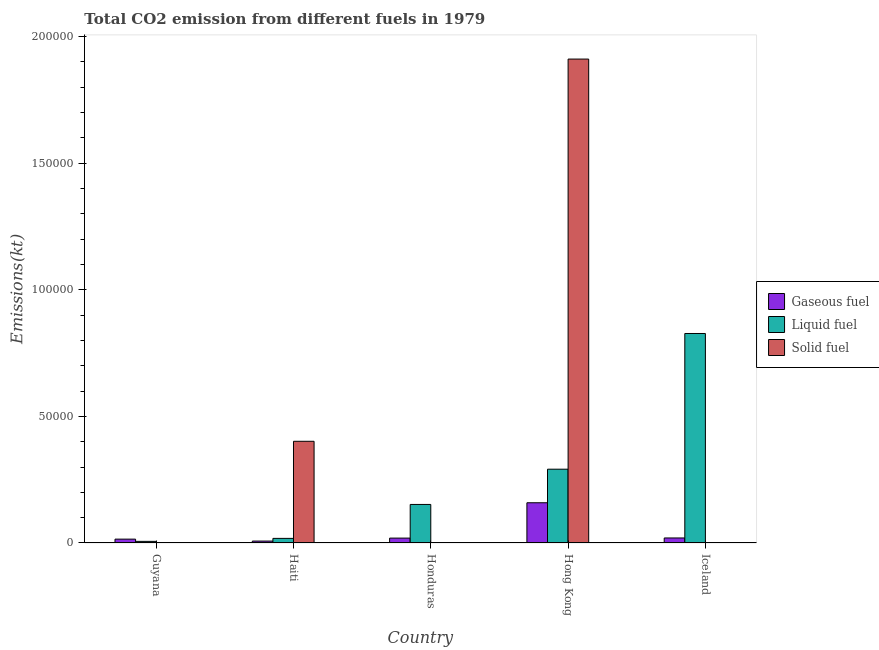How many groups of bars are there?
Keep it short and to the point. 5. How many bars are there on the 4th tick from the right?
Provide a short and direct response. 3. What is the label of the 4th group of bars from the left?
Your answer should be compact. Hong Kong. In how many cases, is the number of bars for a given country not equal to the number of legend labels?
Offer a very short reply. 0. What is the amount of co2 emissions from liquid fuel in Hong Kong?
Provide a short and direct response. 2.91e+04. Across all countries, what is the maximum amount of co2 emissions from solid fuel?
Offer a terse response. 1.91e+05. Across all countries, what is the minimum amount of co2 emissions from solid fuel?
Offer a very short reply. 3.67. In which country was the amount of co2 emissions from solid fuel maximum?
Ensure brevity in your answer.  Hong Kong. In which country was the amount of co2 emissions from liquid fuel minimum?
Offer a very short reply. Guyana. What is the total amount of co2 emissions from liquid fuel in the graph?
Ensure brevity in your answer.  1.30e+05. What is the difference between the amount of co2 emissions from liquid fuel in Honduras and that in Iceland?
Ensure brevity in your answer.  -6.75e+04. What is the difference between the amount of co2 emissions from gaseous fuel in Guyana and the amount of co2 emissions from liquid fuel in Haiti?
Offer a terse response. -297.03. What is the average amount of co2 emissions from liquid fuel per country?
Ensure brevity in your answer.  2.59e+04. What is the difference between the amount of co2 emissions from liquid fuel and amount of co2 emissions from solid fuel in Guyana?
Your response must be concise. 623.39. What is the ratio of the amount of co2 emissions from liquid fuel in Haiti to that in Hong Kong?
Ensure brevity in your answer.  0.06. Is the amount of co2 emissions from gaseous fuel in Honduras less than that in Hong Kong?
Your answer should be very brief. Yes. What is the difference between the highest and the second highest amount of co2 emissions from gaseous fuel?
Keep it short and to the point. 1.39e+04. What is the difference between the highest and the lowest amount of co2 emissions from gaseous fuel?
Offer a terse response. 1.51e+04. What does the 3rd bar from the left in Haiti represents?
Your response must be concise. Solid fuel. What does the 2nd bar from the right in Hong Kong represents?
Keep it short and to the point. Liquid fuel. Is it the case that in every country, the sum of the amount of co2 emissions from gaseous fuel and amount of co2 emissions from liquid fuel is greater than the amount of co2 emissions from solid fuel?
Keep it short and to the point. No. Are all the bars in the graph horizontal?
Your answer should be very brief. No. How many countries are there in the graph?
Keep it short and to the point. 5. What is the difference between two consecutive major ticks on the Y-axis?
Your answer should be very brief. 5.00e+04. Does the graph contain grids?
Offer a very short reply. No. How are the legend labels stacked?
Your answer should be very brief. Vertical. What is the title of the graph?
Offer a terse response. Total CO2 emission from different fuels in 1979. What is the label or title of the X-axis?
Provide a succinct answer. Country. What is the label or title of the Y-axis?
Give a very brief answer. Emissions(kt). What is the Emissions(kt) of Gaseous fuel in Guyana?
Ensure brevity in your answer.  1521.81. What is the Emissions(kt) of Liquid fuel in Guyana?
Give a very brief answer. 638.06. What is the Emissions(kt) of Solid fuel in Guyana?
Offer a very short reply. 14.67. What is the Emissions(kt) in Gaseous fuel in Haiti?
Provide a succinct answer. 755.4. What is the Emissions(kt) of Liquid fuel in Haiti?
Give a very brief answer. 1818.83. What is the Emissions(kt) of Solid fuel in Haiti?
Make the answer very short. 4.02e+04. What is the Emissions(kt) in Gaseous fuel in Honduras?
Provide a short and direct response. 1932.51. What is the Emissions(kt) of Liquid fuel in Honduras?
Your answer should be very brief. 1.52e+04. What is the Emissions(kt) of Solid fuel in Honduras?
Offer a very short reply. 3.67. What is the Emissions(kt) of Gaseous fuel in Hong Kong?
Make the answer very short. 1.59e+04. What is the Emissions(kt) in Liquid fuel in Hong Kong?
Provide a succinct answer. 2.91e+04. What is the Emissions(kt) in Solid fuel in Hong Kong?
Provide a succinct answer. 1.91e+05. What is the Emissions(kt) of Gaseous fuel in Iceland?
Your response must be concise. 1987.51. What is the Emissions(kt) of Liquid fuel in Iceland?
Provide a short and direct response. 8.27e+04. What is the Emissions(kt) of Solid fuel in Iceland?
Your answer should be very brief. 44. Across all countries, what is the maximum Emissions(kt) of Gaseous fuel?
Your response must be concise. 1.59e+04. Across all countries, what is the maximum Emissions(kt) of Liquid fuel?
Give a very brief answer. 8.27e+04. Across all countries, what is the maximum Emissions(kt) in Solid fuel?
Provide a succinct answer. 1.91e+05. Across all countries, what is the minimum Emissions(kt) in Gaseous fuel?
Your response must be concise. 755.4. Across all countries, what is the minimum Emissions(kt) in Liquid fuel?
Your answer should be compact. 638.06. Across all countries, what is the minimum Emissions(kt) in Solid fuel?
Provide a succinct answer. 3.67. What is the total Emissions(kt) in Gaseous fuel in the graph?
Ensure brevity in your answer.  2.21e+04. What is the total Emissions(kt) of Liquid fuel in the graph?
Provide a short and direct response. 1.30e+05. What is the total Emissions(kt) in Solid fuel in the graph?
Your answer should be compact. 2.31e+05. What is the difference between the Emissions(kt) in Gaseous fuel in Guyana and that in Haiti?
Keep it short and to the point. 766.4. What is the difference between the Emissions(kt) in Liquid fuel in Guyana and that in Haiti?
Make the answer very short. -1180.77. What is the difference between the Emissions(kt) of Solid fuel in Guyana and that in Haiti?
Offer a terse response. -4.01e+04. What is the difference between the Emissions(kt) of Gaseous fuel in Guyana and that in Honduras?
Provide a succinct answer. -410.7. What is the difference between the Emissions(kt) of Liquid fuel in Guyana and that in Honduras?
Give a very brief answer. -1.46e+04. What is the difference between the Emissions(kt) in Solid fuel in Guyana and that in Honduras?
Your answer should be very brief. 11. What is the difference between the Emissions(kt) in Gaseous fuel in Guyana and that in Hong Kong?
Your answer should be compact. -1.44e+04. What is the difference between the Emissions(kt) of Liquid fuel in Guyana and that in Hong Kong?
Your answer should be very brief. -2.85e+04. What is the difference between the Emissions(kt) of Solid fuel in Guyana and that in Hong Kong?
Your answer should be very brief. -1.91e+05. What is the difference between the Emissions(kt) of Gaseous fuel in Guyana and that in Iceland?
Make the answer very short. -465.71. What is the difference between the Emissions(kt) in Liquid fuel in Guyana and that in Iceland?
Offer a very short reply. -8.21e+04. What is the difference between the Emissions(kt) of Solid fuel in Guyana and that in Iceland?
Ensure brevity in your answer.  -29.34. What is the difference between the Emissions(kt) of Gaseous fuel in Haiti and that in Honduras?
Your response must be concise. -1177.11. What is the difference between the Emissions(kt) in Liquid fuel in Haiti and that in Honduras?
Give a very brief answer. -1.34e+04. What is the difference between the Emissions(kt) in Solid fuel in Haiti and that in Honduras?
Your answer should be very brief. 4.02e+04. What is the difference between the Emissions(kt) of Gaseous fuel in Haiti and that in Hong Kong?
Your response must be concise. -1.51e+04. What is the difference between the Emissions(kt) in Liquid fuel in Haiti and that in Hong Kong?
Provide a succinct answer. -2.73e+04. What is the difference between the Emissions(kt) of Solid fuel in Haiti and that in Hong Kong?
Keep it short and to the point. -1.51e+05. What is the difference between the Emissions(kt) in Gaseous fuel in Haiti and that in Iceland?
Make the answer very short. -1232.11. What is the difference between the Emissions(kt) of Liquid fuel in Haiti and that in Iceland?
Keep it short and to the point. -8.09e+04. What is the difference between the Emissions(kt) of Solid fuel in Haiti and that in Iceland?
Keep it short and to the point. 4.01e+04. What is the difference between the Emissions(kt) in Gaseous fuel in Honduras and that in Hong Kong?
Make the answer very short. -1.40e+04. What is the difference between the Emissions(kt) in Liquid fuel in Honduras and that in Hong Kong?
Make the answer very short. -1.39e+04. What is the difference between the Emissions(kt) in Solid fuel in Honduras and that in Hong Kong?
Your answer should be compact. -1.91e+05. What is the difference between the Emissions(kt) in Gaseous fuel in Honduras and that in Iceland?
Keep it short and to the point. -55.01. What is the difference between the Emissions(kt) in Liquid fuel in Honduras and that in Iceland?
Keep it short and to the point. -6.75e+04. What is the difference between the Emissions(kt) of Solid fuel in Honduras and that in Iceland?
Offer a very short reply. -40.34. What is the difference between the Emissions(kt) in Gaseous fuel in Hong Kong and that in Iceland?
Your answer should be compact. 1.39e+04. What is the difference between the Emissions(kt) of Liquid fuel in Hong Kong and that in Iceland?
Make the answer very short. -5.36e+04. What is the difference between the Emissions(kt) of Solid fuel in Hong Kong and that in Iceland?
Keep it short and to the point. 1.91e+05. What is the difference between the Emissions(kt) in Gaseous fuel in Guyana and the Emissions(kt) in Liquid fuel in Haiti?
Your response must be concise. -297.03. What is the difference between the Emissions(kt) of Gaseous fuel in Guyana and the Emissions(kt) of Solid fuel in Haiti?
Ensure brevity in your answer.  -3.86e+04. What is the difference between the Emissions(kt) of Liquid fuel in Guyana and the Emissions(kt) of Solid fuel in Haiti?
Offer a very short reply. -3.95e+04. What is the difference between the Emissions(kt) in Gaseous fuel in Guyana and the Emissions(kt) in Liquid fuel in Honduras?
Offer a very short reply. -1.37e+04. What is the difference between the Emissions(kt) in Gaseous fuel in Guyana and the Emissions(kt) in Solid fuel in Honduras?
Keep it short and to the point. 1518.14. What is the difference between the Emissions(kt) of Liquid fuel in Guyana and the Emissions(kt) of Solid fuel in Honduras?
Ensure brevity in your answer.  634.39. What is the difference between the Emissions(kt) of Gaseous fuel in Guyana and the Emissions(kt) of Liquid fuel in Hong Kong?
Provide a succinct answer. -2.76e+04. What is the difference between the Emissions(kt) in Gaseous fuel in Guyana and the Emissions(kt) in Solid fuel in Hong Kong?
Your response must be concise. -1.90e+05. What is the difference between the Emissions(kt) in Liquid fuel in Guyana and the Emissions(kt) in Solid fuel in Hong Kong?
Your answer should be compact. -1.90e+05. What is the difference between the Emissions(kt) of Gaseous fuel in Guyana and the Emissions(kt) of Liquid fuel in Iceland?
Your answer should be compact. -8.12e+04. What is the difference between the Emissions(kt) in Gaseous fuel in Guyana and the Emissions(kt) in Solid fuel in Iceland?
Ensure brevity in your answer.  1477.8. What is the difference between the Emissions(kt) in Liquid fuel in Guyana and the Emissions(kt) in Solid fuel in Iceland?
Offer a very short reply. 594.05. What is the difference between the Emissions(kt) in Gaseous fuel in Haiti and the Emissions(kt) in Liquid fuel in Honduras?
Your answer should be very brief. -1.45e+04. What is the difference between the Emissions(kt) of Gaseous fuel in Haiti and the Emissions(kt) of Solid fuel in Honduras?
Provide a succinct answer. 751.74. What is the difference between the Emissions(kt) in Liquid fuel in Haiti and the Emissions(kt) in Solid fuel in Honduras?
Ensure brevity in your answer.  1815.16. What is the difference between the Emissions(kt) in Gaseous fuel in Haiti and the Emissions(kt) in Liquid fuel in Hong Kong?
Make the answer very short. -2.84e+04. What is the difference between the Emissions(kt) in Gaseous fuel in Haiti and the Emissions(kt) in Solid fuel in Hong Kong?
Your answer should be very brief. -1.90e+05. What is the difference between the Emissions(kt) of Liquid fuel in Haiti and the Emissions(kt) of Solid fuel in Hong Kong?
Your response must be concise. -1.89e+05. What is the difference between the Emissions(kt) of Gaseous fuel in Haiti and the Emissions(kt) of Liquid fuel in Iceland?
Offer a terse response. -8.20e+04. What is the difference between the Emissions(kt) in Gaseous fuel in Haiti and the Emissions(kt) in Solid fuel in Iceland?
Ensure brevity in your answer.  711.4. What is the difference between the Emissions(kt) of Liquid fuel in Haiti and the Emissions(kt) of Solid fuel in Iceland?
Give a very brief answer. 1774.83. What is the difference between the Emissions(kt) of Gaseous fuel in Honduras and the Emissions(kt) of Liquid fuel in Hong Kong?
Your response must be concise. -2.72e+04. What is the difference between the Emissions(kt) of Gaseous fuel in Honduras and the Emissions(kt) of Solid fuel in Hong Kong?
Give a very brief answer. -1.89e+05. What is the difference between the Emissions(kt) of Liquid fuel in Honduras and the Emissions(kt) of Solid fuel in Hong Kong?
Your response must be concise. -1.76e+05. What is the difference between the Emissions(kt) in Gaseous fuel in Honduras and the Emissions(kt) in Liquid fuel in Iceland?
Ensure brevity in your answer.  -8.08e+04. What is the difference between the Emissions(kt) in Gaseous fuel in Honduras and the Emissions(kt) in Solid fuel in Iceland?
Give a very brief answer. 1888.51. What is the difference between the Emissions(kt) of Liquid fuel in Honduras and the Emissions(kt) of Solid fuel in Iceland?
Offer a very short reply. 1.52e+04. What is the difference between the Emissions(kt) in Gaseous fuel in Hong Kong and the Emissions(kt) in Liquid fuel in Iceland?
Keep it short and to the point. -6.68e+04. What is the difference between the Emissions(kt) of Gaseous fuel in Hong Kong and the Emissions(kt) of Solid fuel in Iceland?
Offer a terse response. 1.58e+04. What is the difference between the Emissions(kt) of Liquid fuel in Hong Kong and the Emissions(kt) of Solid fuel in Iceland?
Offer a terse response. 2.91e+04. What is the average Emissions(kt) of Gaseous fuel per country?
Offer a very short reply. 4416.53. What is the average Emissions(kt) of Liquid fuel per country?
Your answer should be compact. 2.59e+04. What is the average Emissions(kt) of Solid fuel per country?
Ensure brevity in your answer.  4.63e+04. What is the difference between the Emissions(kt) in Gaseous fuel and Emissions(kt) in Liquid fuel in Guyana?
Provide a short and direct response. 883.75. What is the difference between the Emissions(kt) of Gaseous fuel and Emissions(kt) of Solid fuel in Guyana?
Offer a terse response. 1507.14. What is the difference between the Emissions(kt) in Liquid fuel and Emissions(kt) in Solid fuel in Guyana?
Offer a terse response. 623.39. What is the difference between the Emissions(kt) of Gaseous fuel and Emissions(kt) of Liquid fuel in Haiti?
Give a very brief answer. -1063.43. What is the difference between the Emissions(kt) in Gaseous fuel and Emissions(kt) in Solid fuel in Haiti?
Provide a succinct answer. -3.94e+04. What is the difference between the Emissions(kt) of Liquid fuel and Emissions(kt) of Solid fuel in Haiti?
Offer a very short reply. -3.83e+04. What is the difference between the Emissions(kt) of Gaseous fuel and Emissions(kt) of Liquid fuel in Honduras?
Provide a succinct answer. -1.33e+04. What is the difference between the Emissions(kt) in Gaseous fuel and Emissions(kt) in Solid fuel in Honduras?
Your response must be concise. 1928.84. What is the difference between the Emissions(kt) of Liquid fuel and Emissions(kt) of Solid fuel in Honduras?
Ensure brevity in your answer.  1.52e+04. What is the difference between the Emissions(kt) of Gaseous fuel and Emissions(kt) of Liquid fuel in Hong Kong?
Provide a succinct answer. -1.33e+04. What is the difference between the Emissions(kt) in Gaseous fuel and Emissions(kt) in Solid fuel in Hong Kong?
Provide a short and direct response. -1.75e+05. What is the difference between the Emissions(kt) in Liquid fuel and Emissions(kt) in Solid fuel in Hong Kong?
Give a very brief answer. -1.62e+05. What is the difference between the Emissions(kt) in Gaseous fuel and Emissions(kt) in Liquid fuel in Iceland?
Provide a short and direct response. -8.07e+04. What is the difference between the Emissions(kt) in Gaseous fuel and Emissions(kt) in Solid fuel in Iceland?
Provide a short and direct response. 1943.51. What is the difference between the Emissions(kt) of Liquid fuel and Emissions(kt) of Solid fuel in Iceland?
Offer a very short reply. 8.27e+04. What is the ratio of the Emissions(kt) in Gaseous fuel in Guyana to that in Haiti?
Your answer should be very brief. 2.01. What is the ratio of the Emissions(kt) in Liquid fuel in Guyana to that in Haiti?
Ensure brevity in your answer.  0.35. What is the ratio of the Emissions(kt) in Gaseous fuel in Guyana to that in Honduras?
Make the answer very short. 0.79. What is the ratio of the Emissions(kt) of Liquid fuel in Guyana to that in Honduras?
Your response must be concise. 0.04. What is the ratio of the Emissions(kt) in Gaseous fuel in Guyana to that in Hong Kong?
Provide a short and direct response. 0.1. What is the ratio of the Emissions(kt) of Liquid fuel in Guyana to that in Hong Kong?
Make the answer very short. 0.02. What is the ratio of the Emissions(kt) of Solid fuel in Guyana to that in Hong Kong?
Your response must be concise. 0. What is the ratio of the Emissions(kt) of Gaseous fuel in Guyana to that in Iceland?
Provide a short and direct response. 0.77. What is the ratio of the Emissions(kt) of Liquid fuel in Guyana to that in Iceland?
Your answer should be very brief. 0.01. What is the ratio of the Emissions(kt) of Solid fuel in Guyana to that in Iceland?
Make the answer very short. 0.33. What is the ratio of the Emissions(kt) in Gaseous fuel in Haiti to that in Honduras?
Your answer should be compact. 0.39. What is the ratio of the Emissions(kt) in Liquid fuel in Haiti to that in Honduras?
Offer a very short reply. 0.12. What is the ratio of the Emissions(kt) in Solid fuel in Haiti to that in Honduras?
Keep it short and to the point. 1.10e+04. What is the ratio of the Emissions(kt) in Gaseous fuel in Haiti to that in Hong Kong?
Keep it short and to the point. 0.05. What is the ratio of the Emissions(kt) of Liquid fuel in Haiti to that in Hong Kong?
Your answer should be compact. 0.06. What is the ratio of the Emissions(kt) of Solid fuel in Haiti to that in Hong Kong?
Ensure brevity in your answer.  0.21. What is the ratio of the Emissions(kt) in Gaseous fuel in Haiti to that in Iceland?
Provide a short and direct response. 0.38. What is the ratio of the Emissions(kt) in Liquid fuel in Haiti to that in Iceland?
Offer a terse response. 0.02. What is the ratio of the Emissions(kt) of Solid fuel in Haiti to that in Iceland?
Ensure brevity in your answer.  912.67. What is the ratio of the Emissions(kt) in Gaseous fuel in Honduras to that in Hong Kong?
Ensure brevity in your answer.  0.12. What is the ratio of the Emissions(kt) of Liquid fuel in Honduras to that in Hong Kong?
Keep it short and to the point. 0.52. What is the ratio of the Emissions(kt) of Solid fuel in Honduras to that in Hong Kong?
Give a very brief answer. 0. What is the ratio of the Emissions(kt) in Gaseous fuel in Honduras to that in Iceland?
Provide a short and direct response. 0.97. What is the ratio of the Emissions(kt) of Liquid fuel in Honduras to that in Iceland?
Your response must be concise. 0.18. What is the ratio of the Emissions(kt) of Solid fuel in Honduras to that in Iceland?
Your answer should be compact. 0.08. What is the ratio of the Emissions(kt) of Gaseous fuel in Hong Kong to that in Iceland?
Provide a short and direct response. 7.99. What is the ratio of the Emissions(kt) in Liquid fuel in Hong Kong to that in Iceland?
Your answer should be very brief. 0.35. What is the ratio of the Emissions(kt) in Solid fuel in Hong Kong to that in Iceland?
Keep it short and to the point. 4342.67. What is the difference between the highest and the second highest Emissions(kt) in Gaseous fuel?
Your answer should be compact. 1.39e+04. What is the difference between the highest and the second highest Emissions(kt) in Liquid fuel?
Make the answer very short. 5.36e+04. What is the difference between the highest and the second highest Emissions(kt) in Solid fuel?
Give a very brief answer. 1.51e+05. What is the difference between the highest and the lowest Emissions(kt) of Gaseous fuel?
Your answer should be very brief. 1.51e+04. What is the difference between the highest and the lowest Emissions(kt) in Liquid fuel?
Provide a short and direct response. 8.21e+04. What is the difference between the highest and the lowest Emissions(kt) of Solid fuel?
Keep it short and to the point. 1.91e+05. 